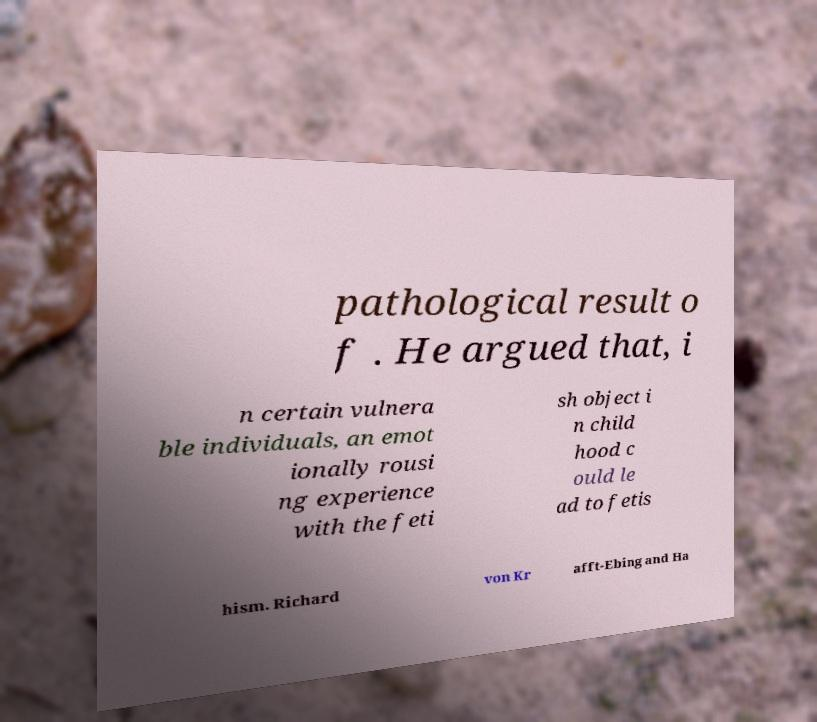There's text embedded in this image that I need extracted. Can you transcribe it verbatim? pathological result o f . He argued that, i n certain vulnera ble individuals, an emot ionally rousi ng experience with the feti sh object i n child hood c ould le ad to fetis hism. Richard von Kr afft-Ebing and Ha 